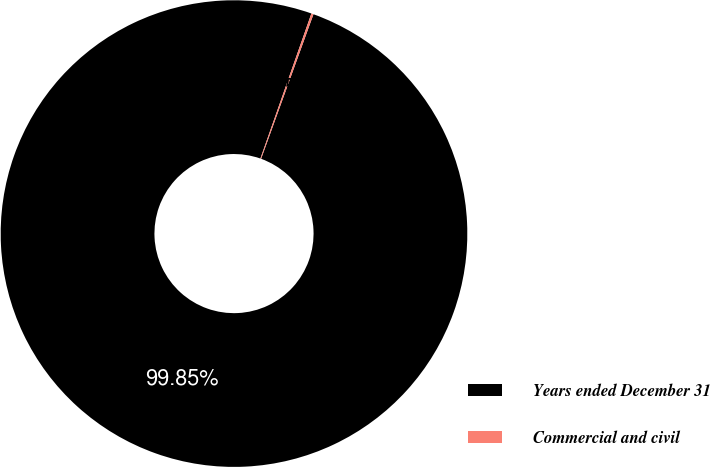Convert chart. <chart><loc_0><loc_0><loc_500><loc_500><pie_chart><fcel>Years ended December 31<fcel>Commercial and civil<nl><fcel>99.85%<fcel>0.15%<nl></chart> 